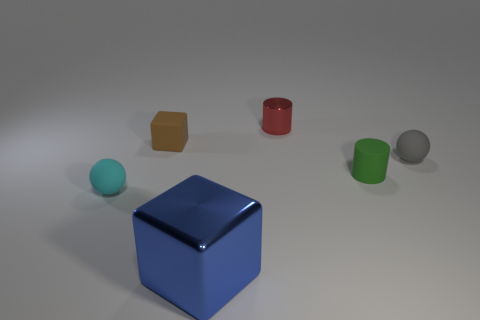What shape is the tiny cyan thing that is made of the same material as the small gray thing?
Ensure brevity in your answer.  Sphere. There is a metallic object that is in front of the tiny shiny thing; is it the same shape as the small brown rubber thing?
Make the answer very short. Yes. How many gray objects are either matte cylinders or tiny things?
Your response must be concise. 1. Is the number of small spheres that are to the right of the green matte cylinder the same as the number of small cylinders to the left of the red cylinder?
Your answer should be compact. No. What is the color of the cube that is on the left side of the metallic object in front of the sphere on the left side of the small gray matte sphere?
Provide a short and direct response. Brown. Are there any other things that have the same color as the matte cylinder?
Give a very brief answer. No. What size is the matte ball on the right side of the tiny red cylinder?
Keep it short and to the point. Small. There is a brown object that is the same size as the cyan object; what is its shape?
Your answer should be very brief. Cube. Are the ball right of the large blue shiny cube and the cylinder that is left of the matte cylinder made of the same material?
Provide a succinct answer. No. The tiny sphere that is right of the rubber ball in front of the gray sphere is made of what material?
Make the answer very short. Rubber. 